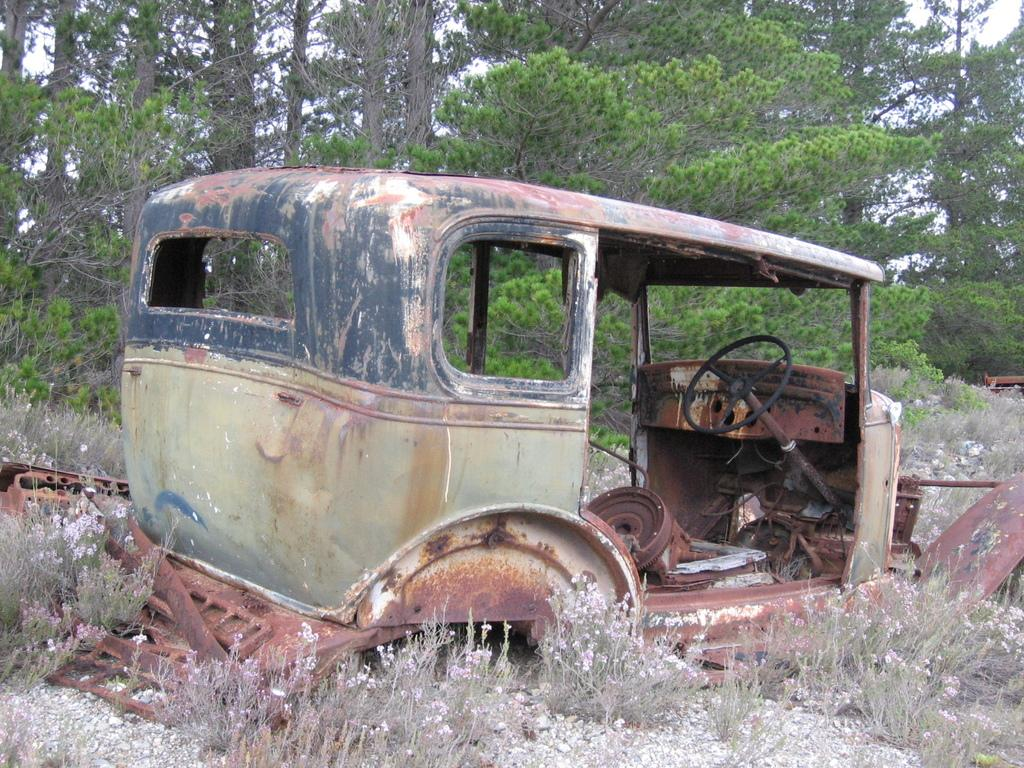What type of vehicle is on the land in the image? The facts do not specify the type of vehicle, but there is a vehicle on the land in the image. What other features can be seen on the land in the image? There are rocks, plants, and metal objects on the land in the image. What is special about the plants in the image? The plants have flowers in the image. What can be seen in the background of the image? There are trees in the background of the image. How many pizzas are being delivered by the vehicle in the image? There is no information about pizzas or delivery in the image, so we cannot determine the number of pizzas being delivered. What type of cloud can be seen in the image? The facts do not mention any clouds in the image, so we cannot describe a cloud in the image. 